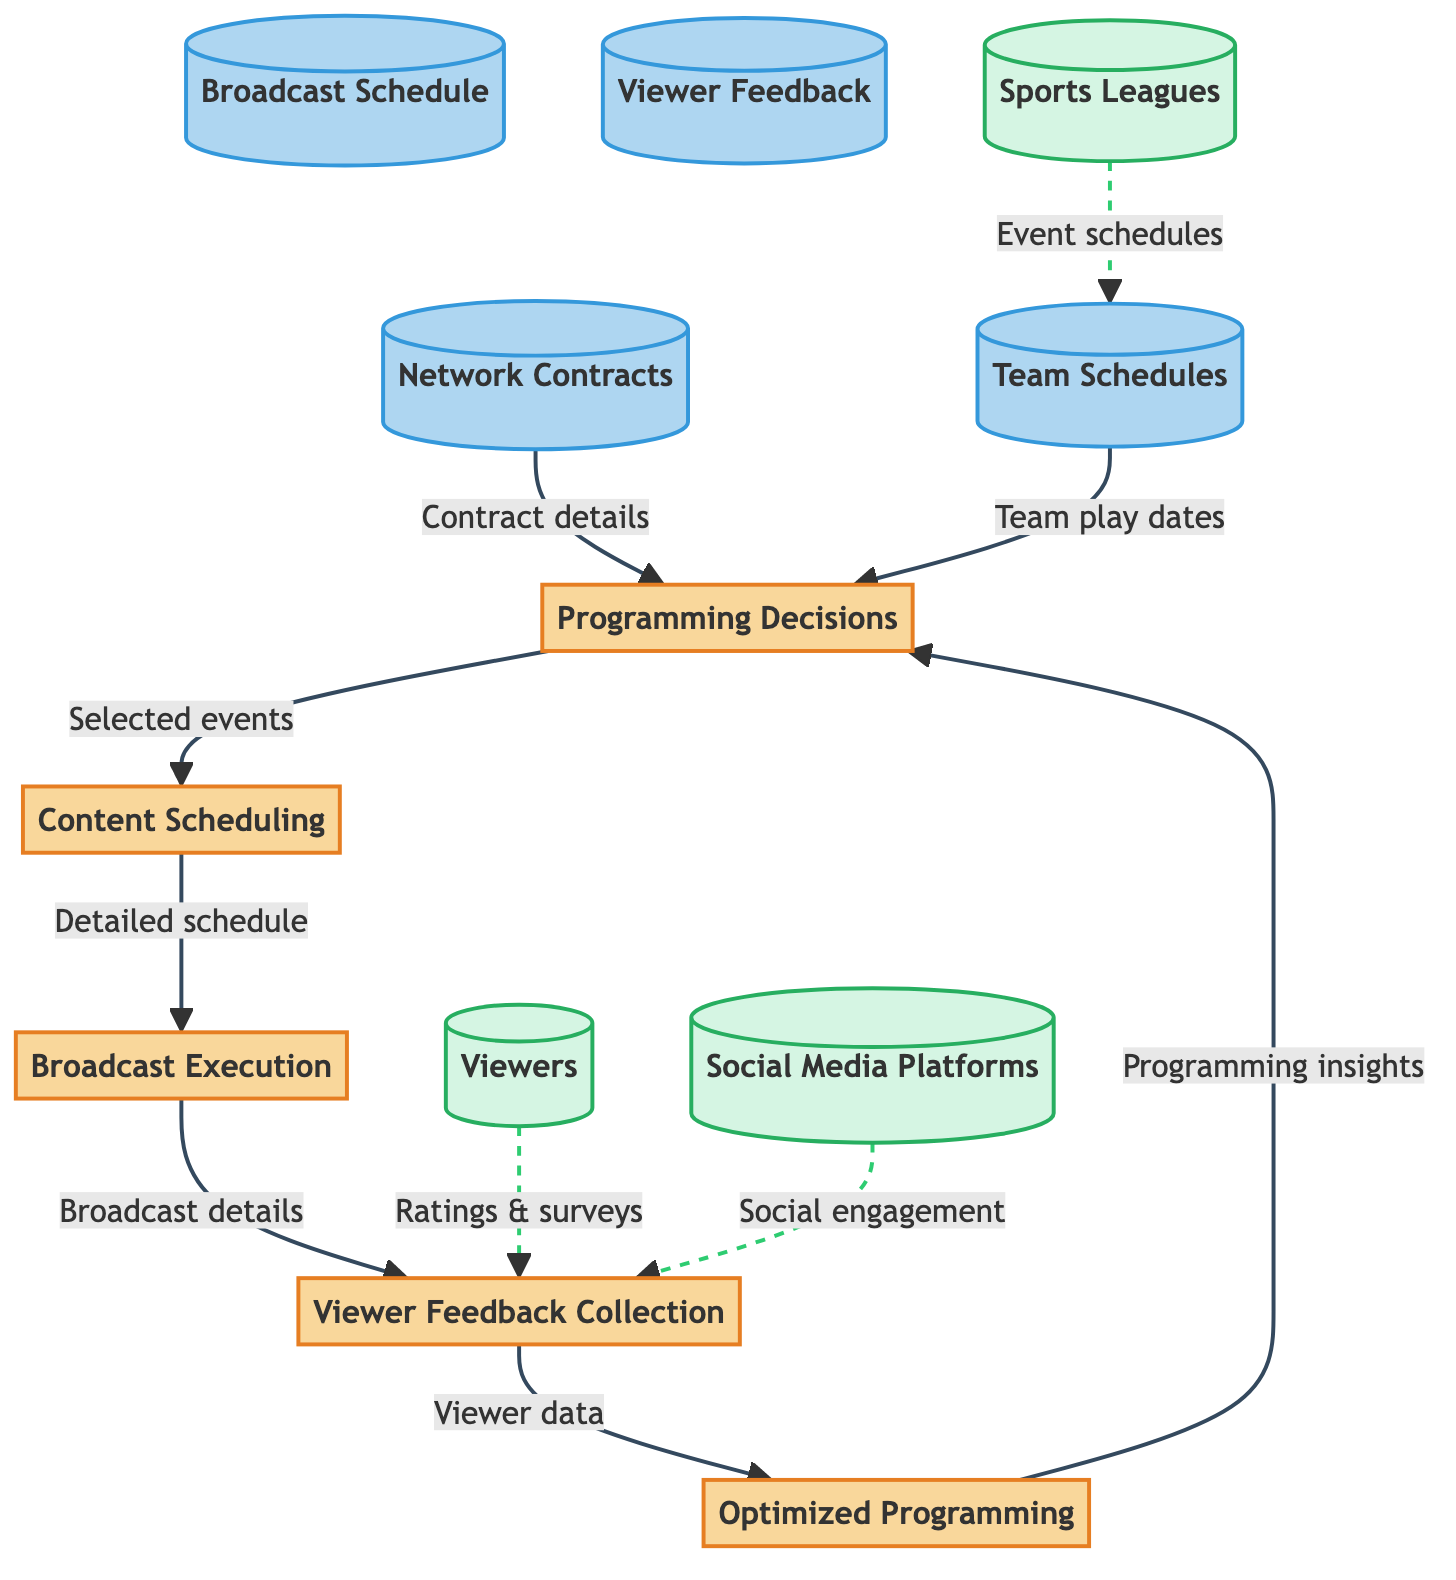What is the first process in the diagram? The diagram lists "Programming Decisions" as Process 1, which is the first process that initiates the flow of information.
Answer: Programming Decisions How many data stores are present in the diagram? There are four distinct data stores identified in the diagram: Network Contracts, Team Schedules, Broadcast Schedule, and Viewer Feedback.
Answer: 4 What type of data do social media platforms provide to viewer feedback collection? The social media platforms provide social engagement data, which is important for assessing viewer interaction and feedback on broadcasts.
Answer: Social engagement Which process directly receives the detailed broadcast schedule? The detailed broadcast schedule is sent directly from the Content Scheduling process to the Broadcast Execution process.
Answer: Broadcast Execution What is the final process that utilizes viewer feedback to influence future actions? "Optimized Programming" is the final process that uses the viewer feedback collected to enhance and refine future programming decisions.
Answer: Optimized Programming Which external entity contributes ratings and surveys to viewer feedback collection? The external entity "Viewers" provides the rating and survey data that are crucial for understanding viewer preferences and satisfaction.
Answer: Viewers How does information flow from optimized programming back to programming decisions? The flow occurs when the Optimized Programming process provides programming insights back to the Programming Decisions process to inform better choices for future broadcasts.
Answer: Programming insights What does the data flow from team schedules to programming decisions represent? The data flow represents the provision of teams' play dates, which are essential for making informed decisions on which sports events to broadcast.
Answer: Team play dates What information is stored in the data store labeled "D4"? The data store labeled "D4" collects viewer data, which includes viewership statistics, social media interactions, and survey results.
Answer: Viewer data 